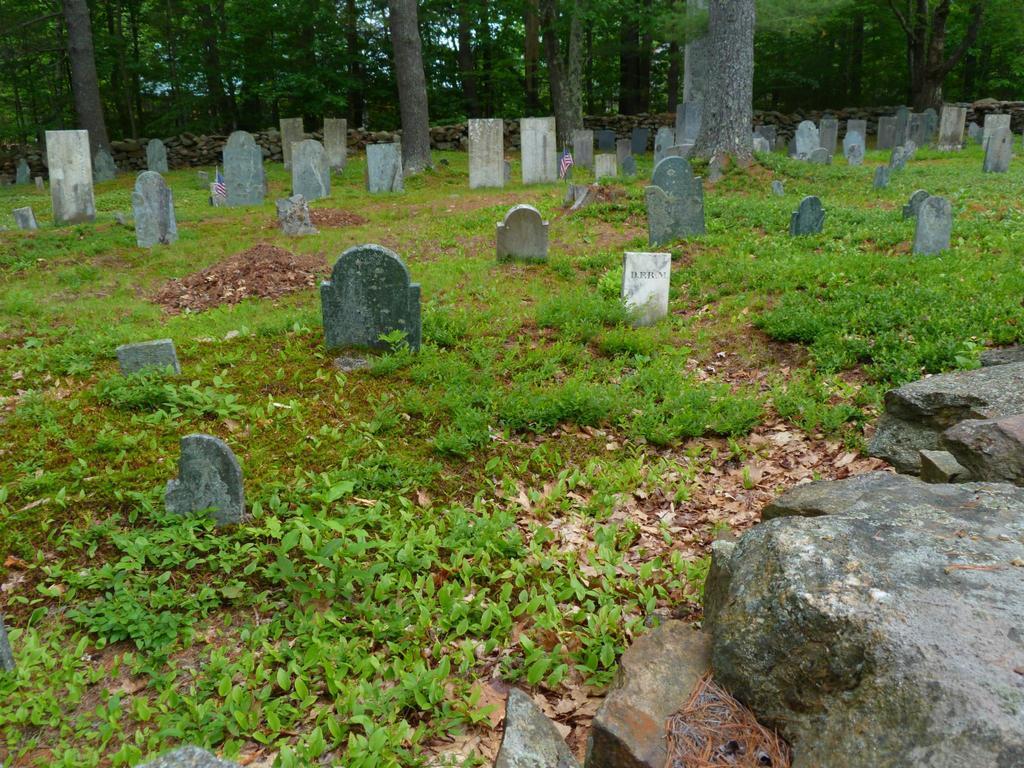Can you describe this image briefly? Here we can see plants, grass, and stone plates. In the background there are trees. 